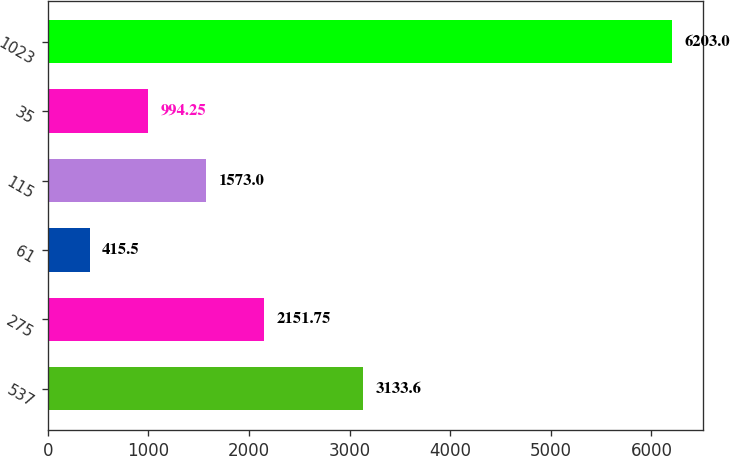Convert chart to OTSL. <chart><loc_0><loc_0><loc_500><loc_500><bar_chart><fcel>537<fcel>275<fcel>61<fcel>115<fcel>35<fcel>1023<nl><fcel>3133.6<fcel>2151.75<fcel>415.5<fcel>1573<fcel>994.25<fcel>6203<nl></chart> 